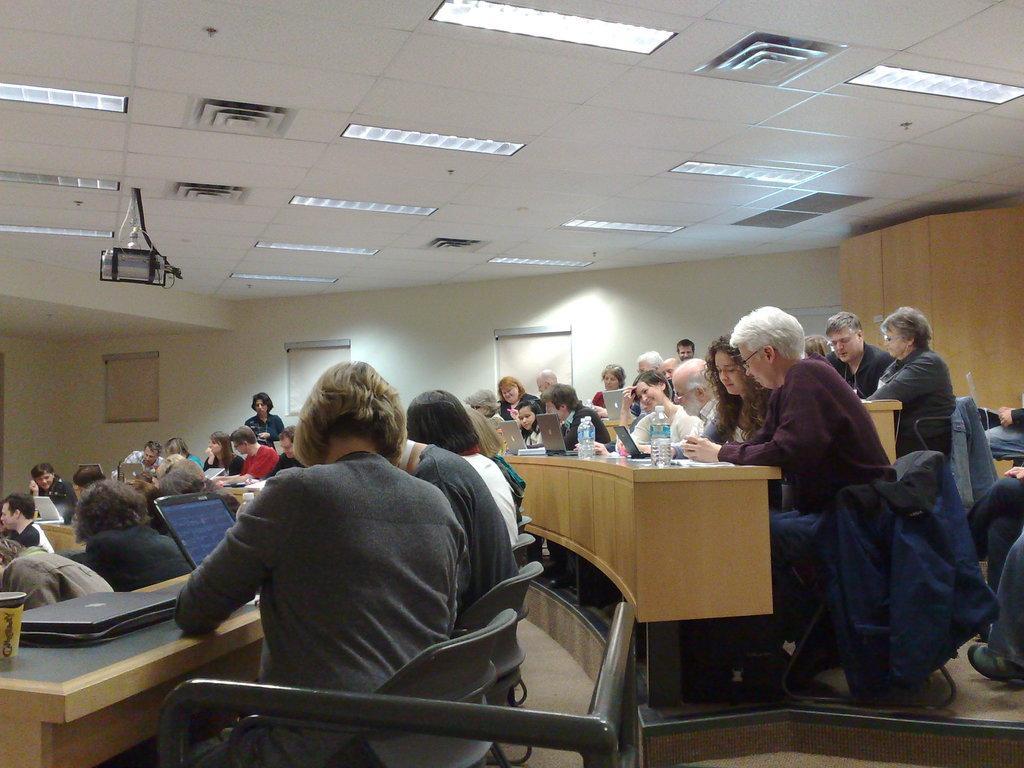Describe this image in one or two sentences. This picture describe a inside view of the seminar hall in which a group of woman and man are sitting on the chair and discussing something. In desk table we can see a woman wearing grey t- shirt is sitting on the chair and discussing with beside man on the laptop and behind a old woman wearing purple shirt is seeing in the mobile, Behind we can see the wooden panel and a wall in which three projector screen rolling down, On the top ceiling we can see the light fixture and ac duct and projector lens hanging. 